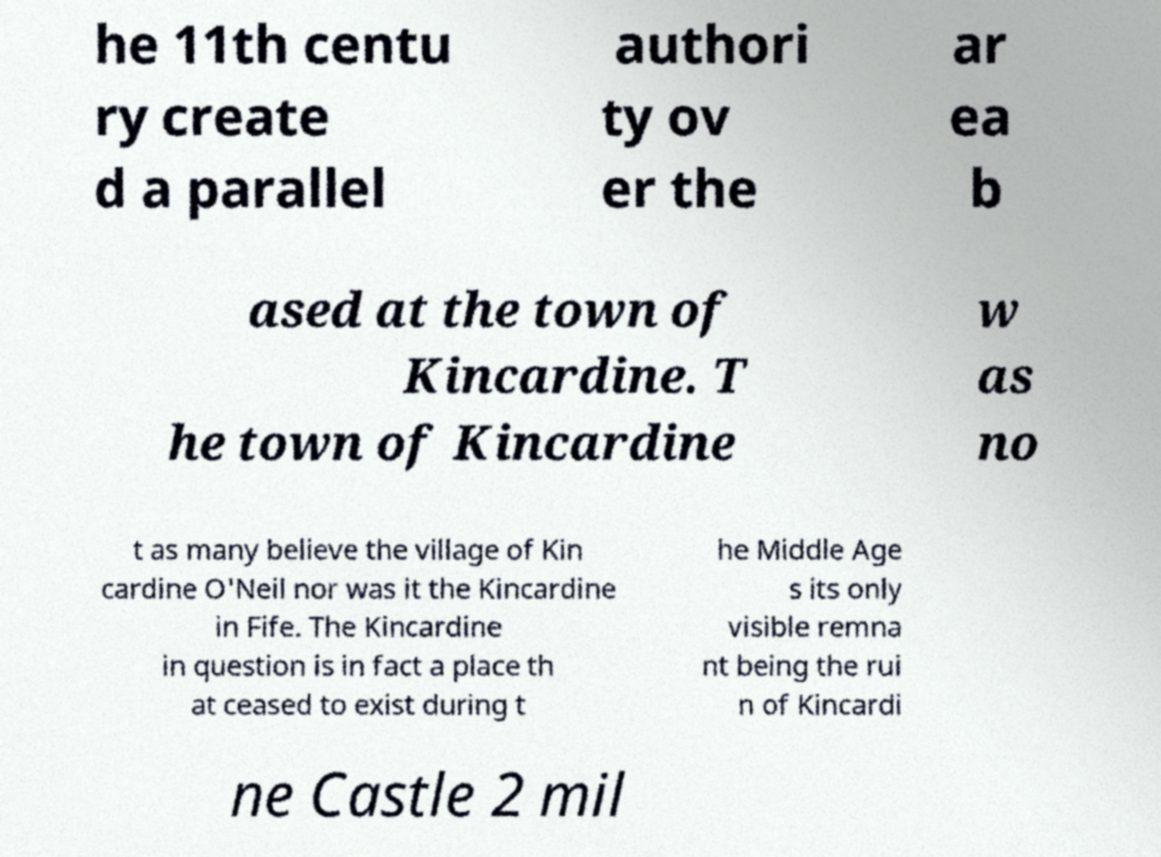There's text embedded in this image that I need extracted. Can you transcribe it verbatim? he 11th centu ry create d a parallel authori ty ov er the ar ea b ased at the town of Kincardine. T he town of Kincardine w as no t as many believe the village of Kin cardine O'Neil nor was it the Kincardine in Fife. The Kincardine in question is in fact a place th at ceased to exist during t he Middle Age s its only visible remna nt being the rui n of Kincardi ne Castle 2 mil 